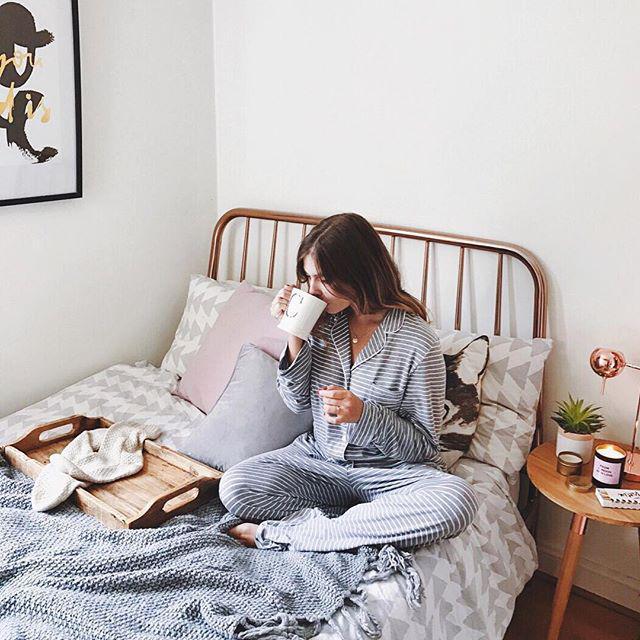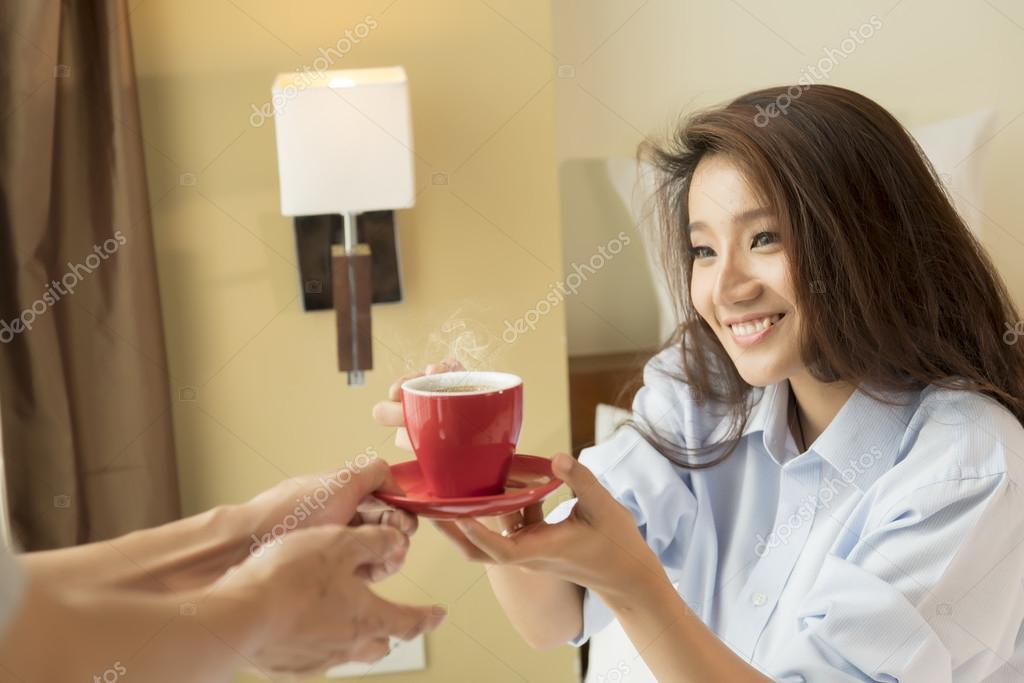The first image is the image on the left, the second image is the image on the right. Examine the images to the left and right. Is the description "In one image a woman is sitting on a bed with her legs crossed and holding a beverage in a white cup." accurate? Answer yes or no. Yes. The first image is the image on the left, the second image is the image on the right. For the images shown, is this caption "The left image contains a human sitting on a bed holding a coffee cup." true? Answer yes or no. Yes. 